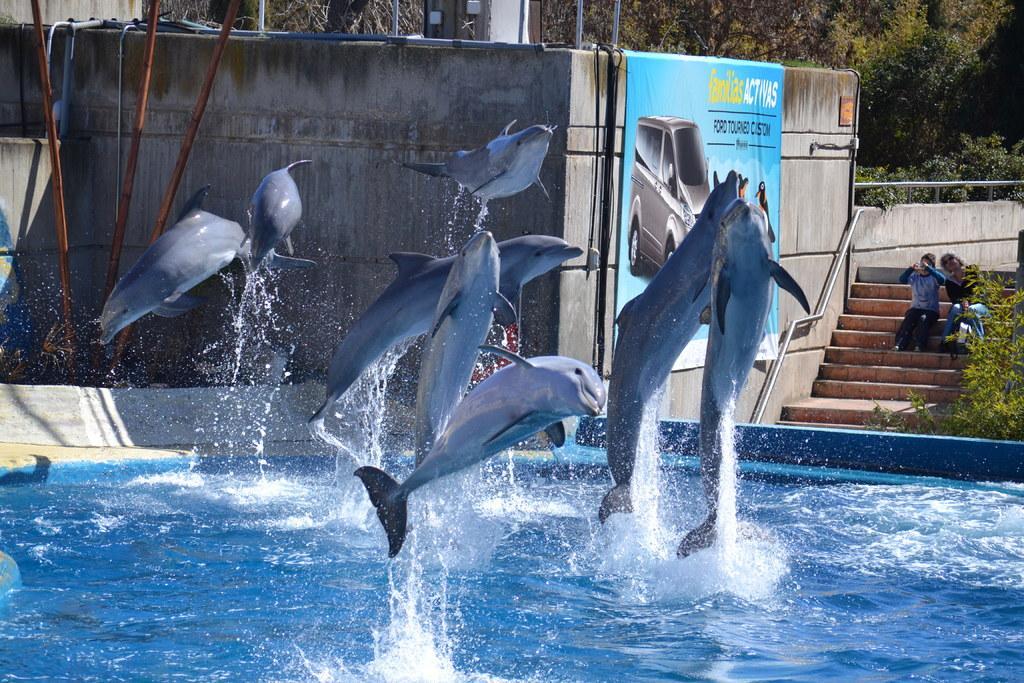Describe this image in one or two sentences. In this picture we can see dolphins, here we can see water, pipes, wall, on this wall we can see a poster on it and we can see a fence, people sitting on steps and in the background we can see trees. 